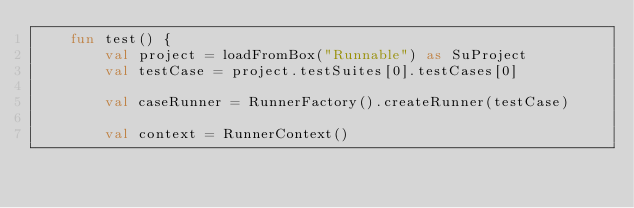Convert code to text. <code><loc_0><loc_0><loc_500><loc_500><_Kotlin_>    fun test() {
        val project = loadFromBox("Runnable") as SuProject
        val testCase = project.testSuites[0].testCases[0]

        val caseRunner = RunnerFactory().createRunner(testCase)

        val context = RunnerContext()</code> 